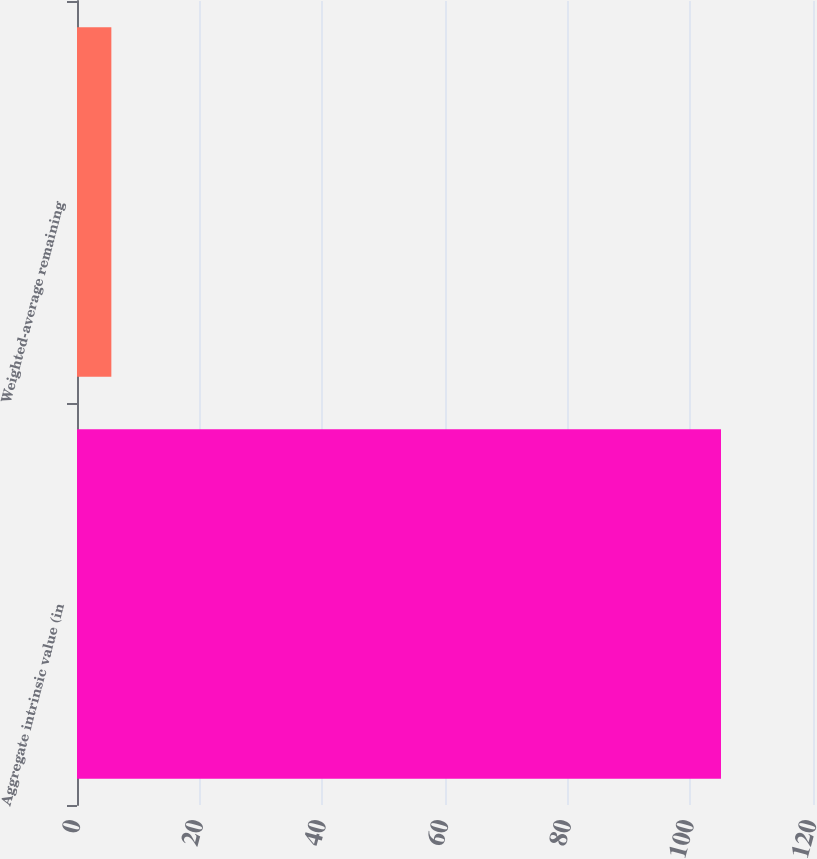<chart> <loc_0><loc_0><loc_500><loc_500><bar_chart><fcel>Aggregate intrinsic value (in<fcel>Weighted-average remaining<nl><fcel>105<fcel>5.6<nl></chart> 